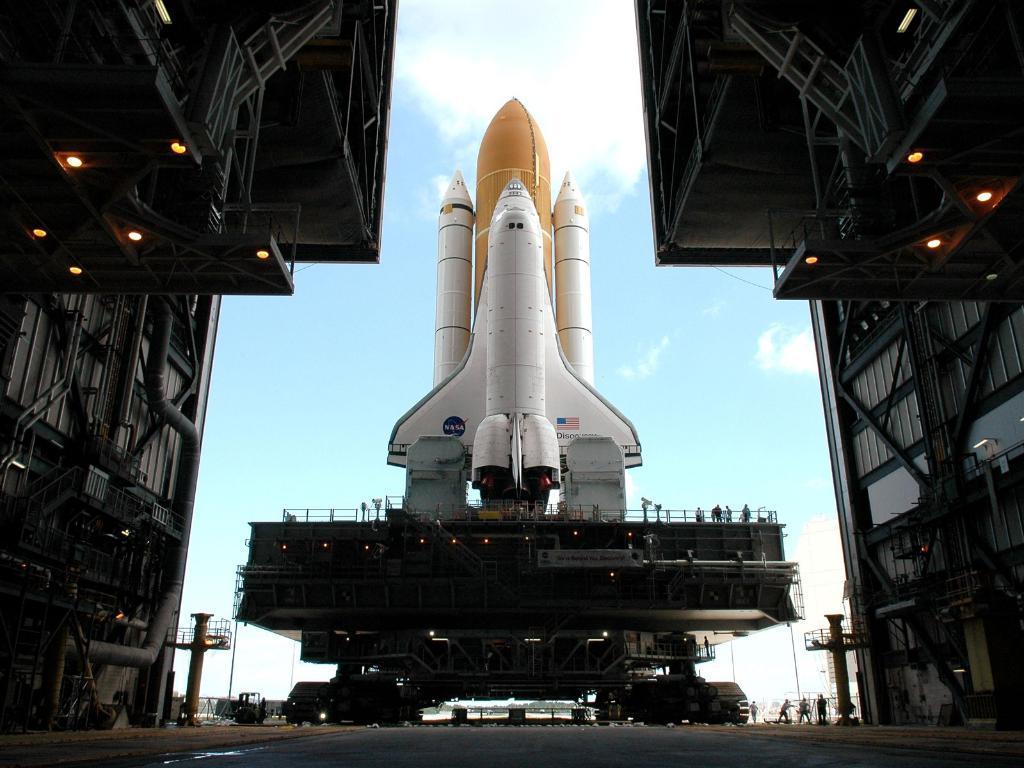Describe this image in one or two sentences. In the middle of the image we can see a satellite on the crane and sky with clouds. On the right side of the image we can see iron grill, poles and electrical lights. On the left side of the image we can see iron grill, pipelines, electrical lights, pole, motor vehicle and persons. 